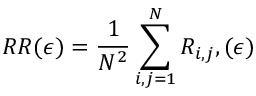<formula> <loc_0><loc_0><loc_500><loc_500>R R ( \epsilon ) = \frac { 1 } { N ^ { 2 } } \sum _ { i , j = 1 } ^ { N } R _ { i , j } , ( \epsilon )</formula> 